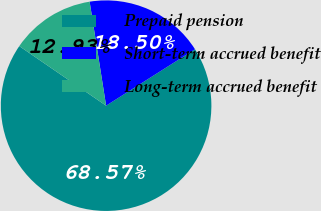<chart> <loc_0><loc_0><loc_500><loc_500><pie_chart><fcel>Prepaid pension<fcel>Short-term accrued benefit<fcel>Long-term accrued benefit<nl><fcel>68.57%<fcel>18.5%<fcel>12.93%<nl></chart> 